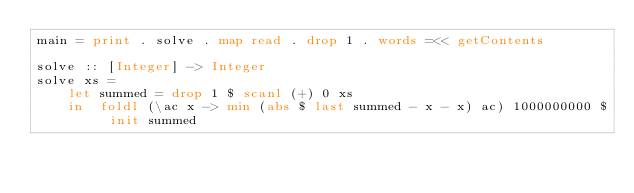Convert code to text. <code><loc_0><loc_0><loc_500><loc_500><_Haskell_>main = print . solve . map read . drop 1 . words =<< getContents

solve :: [Integer] -> Integer
solve xs =
    let summed = drop 1 $ scanl (+) 0 xs
    in  foldl (\ac x -> min (abs $ last summed - x - x) ac) 1000000000 $ init summed
</code> 